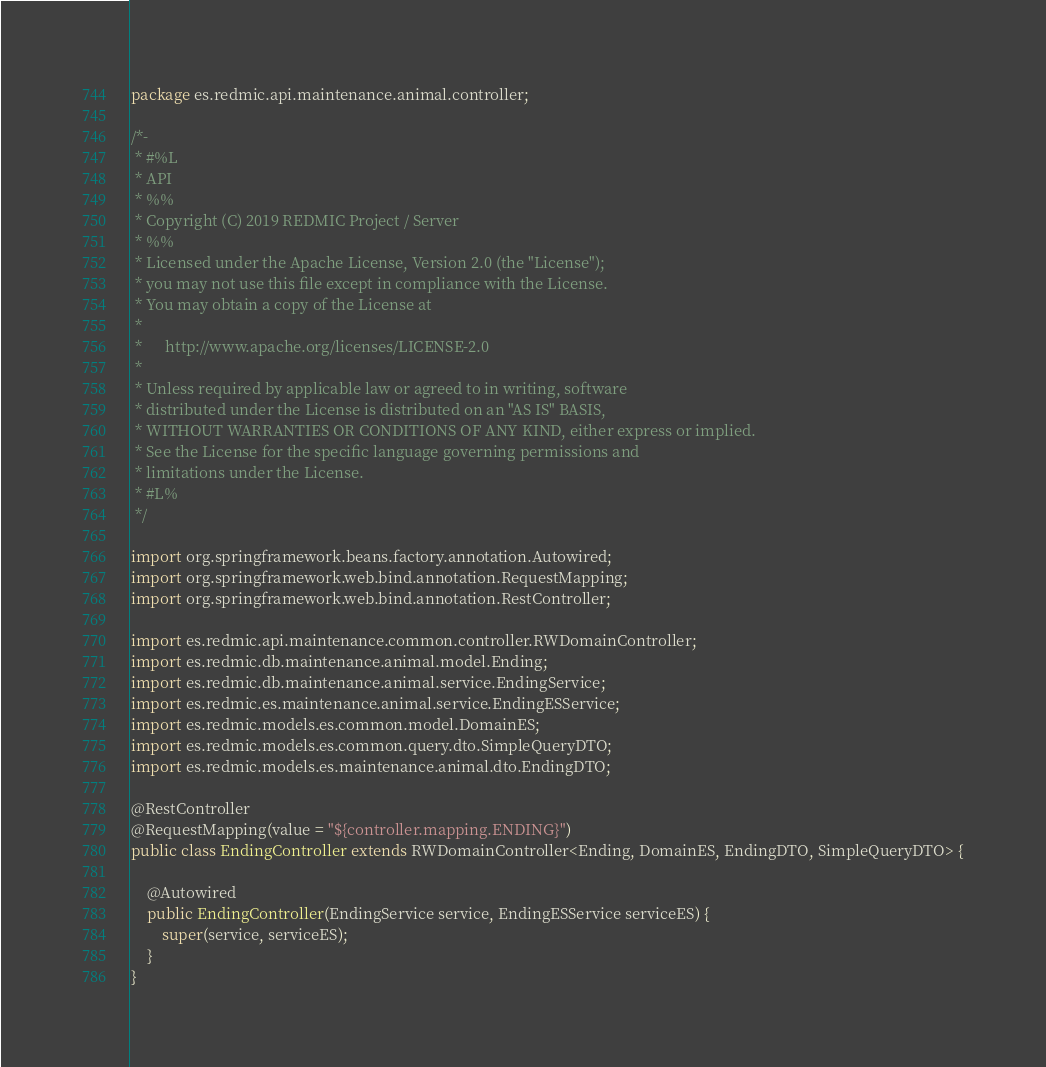<code> <loc_0><loc_0><loc_500><loc_500><_Java_>package es.redmic.api.maintenance.animal.controller;

/*-
 * #%L
 * API
 * %%
 * Copyright (C) 2019 REDMIC Project / Server
 * %%
 * Licensed under the Apache License, Version 2.0 (the "License");
 * you may not use this file except in compliance with the License.
 * You may obtain a copy of the License at
 * 
 *      http://www.apache.org/licenses/LICENSE-2.0
 * 
 * Unless required by applicable law or agreed to in writing, software
 * distributed under the License is distributed on an "AS IS" BASIS,
 * WITHOUT WARRANTIES OR CONDITIONS OF ANY KIND, either express or implied.
 * See the License for the specific language governing permissions and
 * limitations under the License.
 * #L%
 */

import org.springframework.beans.factory.annotation.Autowired;
import org.springframework.web.bind.annotation.RequestMapping;
import org.springframework.web.bind.annotation.RestController;

import es.redmic.api.maintenance.common.controller.RWDomainController;
import es.redmic.db.maintenance.animal.model.Ending;
import es.redmic.db.maintenance.animal.service.EndingService;
import es.redmic.es.maintenance.animal.service.EndingESService;
import es.redmic.models.es.common.model.DomainES;
import es.redmic.models.es.common.query.dto.SimpleQueryDTO;
import es.redmic.models.es.maintenance.animal.dto.EndingDTO;

@RestController
@RequestMapping(value = "${controller.mapping.ENDING}")
public class EndingController extends RWDomainController<Ending, DomainES, EndingDTO, SimpleQueryDTO> {

	@Autowired
	public EndingController(EndingService service, EndingESService serviceES) {
		super(service, serviceES);
	}
}
</code> 